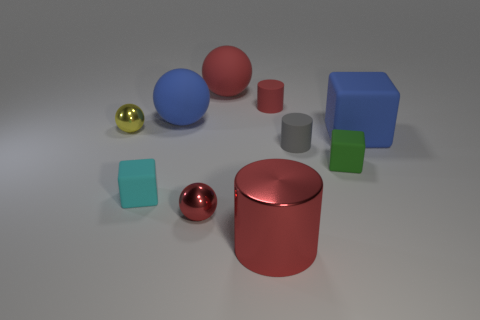How many red cylinders must be subtracted to get 1 red cylinders? 1 Subtract all balls. How many objects are left? 6 Subtract 0 blue cylinders. How many objects are left? 10 Subtract all tiny gray metal balls. Subtract all yellow spheres. How many objects are left? 9 Add 2 red objects. How many red objects are left? 6 Add 9 small cyan matte spheres. How many small cyan matte spheres exist? 9 